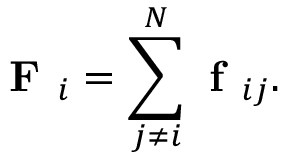<formula> <loc_0><loc_0><loc_500><loc_500>F _ { i } = \sum _ { j \neq i } ^ { N } f _ { i j } .</formula> 